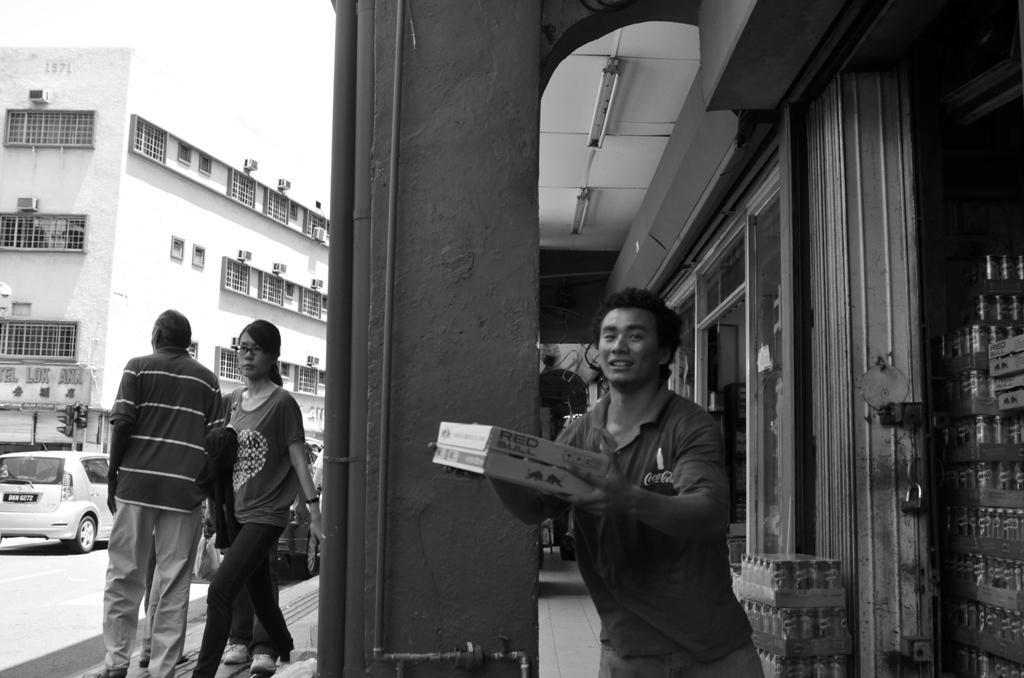Describe this image in one or two sentences. In the picture we can see a building with a pillar near it, we can see a man standing and holding a box with his hands and behind him we can see some shops and to the ceiling we can see some lights and outside the pillar we can see two people are walking on the path and beside them we can see some vehicles on the road and beside it we can see a building with many windows to it. 